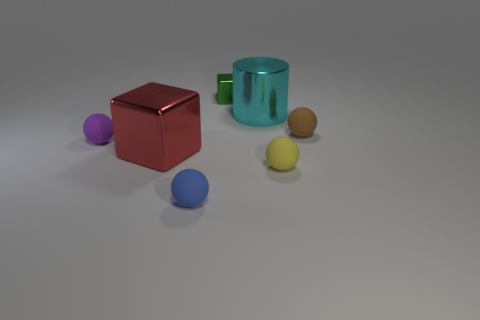Is there a tiny brown rubber thing that has the same shape as the small blue thing?
Offer a very short reply. Yes. There is a big thing left of the cylinder; is it the same shape as the tiny thing behind the brown ball?
Your response must be concise. Yes. How many objects are tiny brown rubber balls or red objects?
Provide a short and direct response. 2. What is the size of the yellow object that is the same shape as the purple thing?
Make the answer very short. Small. Are there more tiny purple objects right of the cylinder than yellow matte spheres?
Give a very brief answer. No. Is the material of the tiny blue thing the same as the cylinder?
Provide a succinct answer. No. How many things are big objects to the left of the cyan cylinder or shiny objects behind the tiny brown thing?
Provide a short and direct response. 3. There is another object that is the same shape as the large red shiny thing; what color is it?
Provide a short and direct response. Green. How many large shiny things are the same color as the large metal cylinder?
Make the answer very short. 0. Is the color of the small cube the same as the cylinder?
Your answer should be compact. No. 